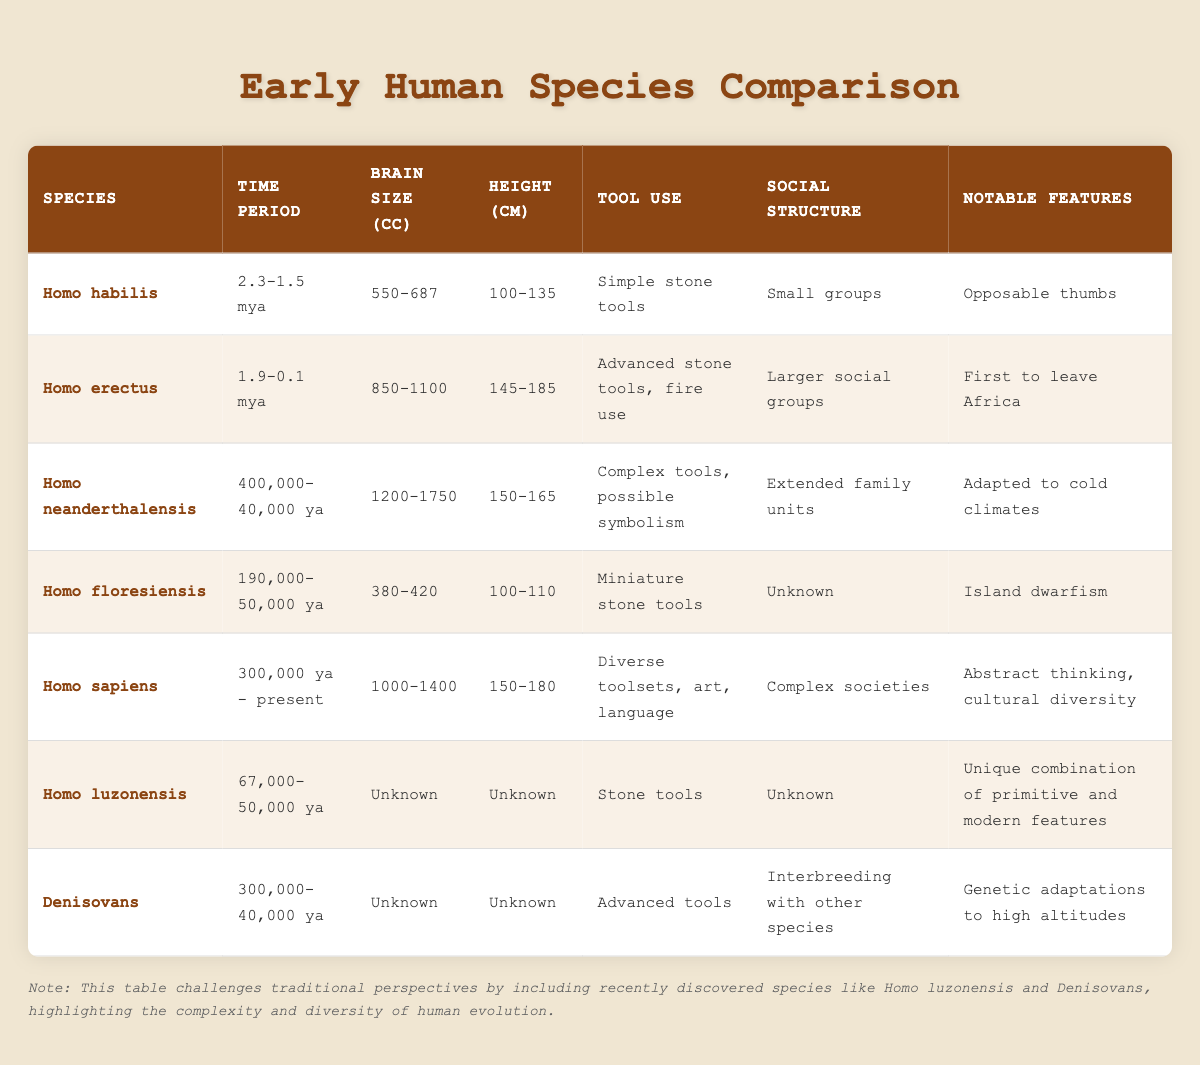What is the brain size range of Homo habilis? The brain size of Homo habilis is listed in the table as 550-687 cc. This information can be found in the "Brain Size (cc)" column corresponding to the row for Homo habilis.
Answer: 550-687 cc Which species had the largest height range? By examining the height ranges provided, Homo neanderthalensis has the largest height range of 150-165 cm. Other species have smaller or equal ranges but do not exceed this height range.
Answer: Homo neanderthalensis Did Homo erectus use fire? Yes, according to the table, Homo erectus is noted for using advanced stone tools and fire use in the "Tool Use" column. This indicates that they indeed utilized fire.
Answer: Yes What is the notable feature of Homo floresiensis? The notable feature listed for Homo floresiensis is "Island dwarfism," which indicates a specific evolutionary adaptation. This fact is found in the "Notable Features" column for Homo floresiensis.
Answer: Island dwarfism What is the average brain size of the species listed excluding Homo luzonensis and Denisovans? First, we sum the brain sizes: Homo habilis (550-687), Homo erectus (850-1100), Homo neanderthalensis (1200-1750), and Homo sapiens (1000-1400). For the calculations, we will consider the lowest and highest values for each: 550 + 850 + 1200 + 1000 = 3600 (lowest values) and 687 + 1100 + 1750 + 1400 = 3937 (highest values). There are 4 species, so the averages are 3600/4 = 900 and 3937/4 = 984.25.
Answer: 900-984.25 How many species mentioned had known social structures? The table lists social structures for Homo habilis (small groups), Homo erectus (larger social groups), Homo neanderthalensis (extended family units), Homo sapiens (complex societies), and Homo floresiensis (unknown). The species with known social structures are Homo habilis, Homo erectus, Homo neanderthalensis, and Homo sapiens, totaling 4. The information comes from the "Social Structure" column.
Answer: 4 Which species had the smallest brain size? Homo floresiensis had the smallest brain size, listed as 380-420 cc in the "Brain Size (cc)" column. By comparing brain sizes of all species, no other species falls below this range.
Answer: Homo floresiensis What is the notable feature difference between Homo sapiens and Homo neanderthalensis? Homo sapiens are noted for "Abstract thinking, cultural diversity," while Homo neanderthalensis is known for being "Adapted to cold climates." This comparison can be found in the "Notable Features" column.
Answer: Abstract thinking, cultural diversity vs. Adapted to cold climates How many species were present in the table from the time period of 300,000 to 0 years ago? The species present from this time period are Homo sapiens, Homo luzonensis, and Denisovans, which total 3 species. This is determined by checking the "Time Period" for each species listed in the table.
Answer: 3 